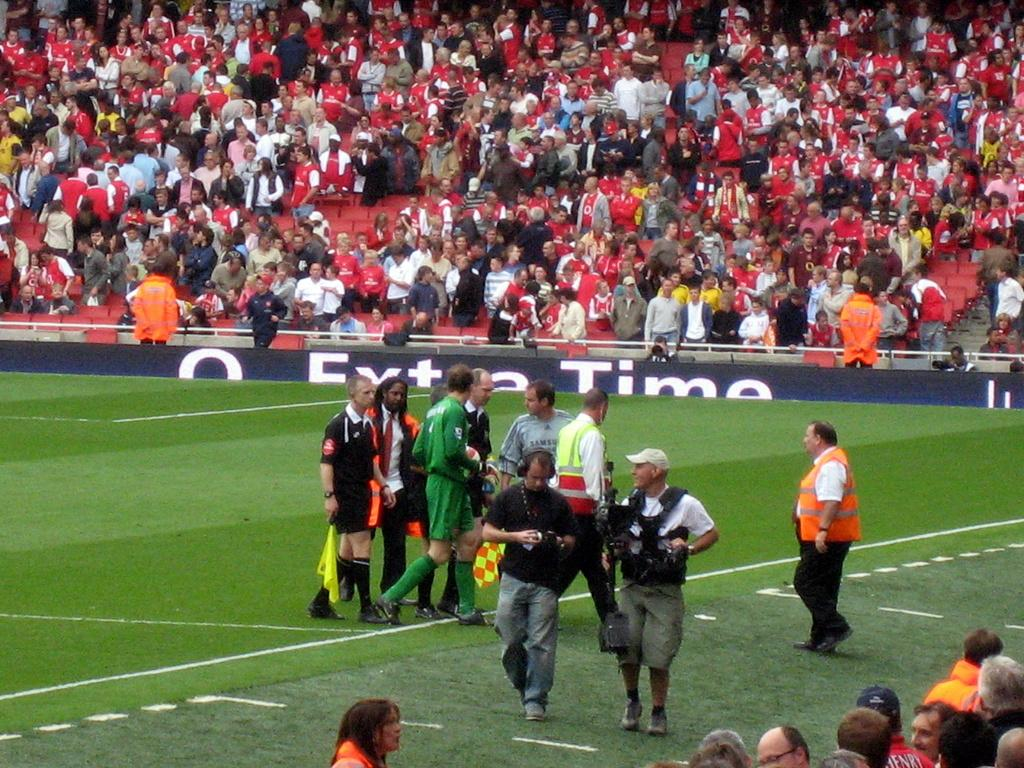Provide a one-sentence caption for the provided image. a soccer field with a sideline banner that says 'extra time' on it. 